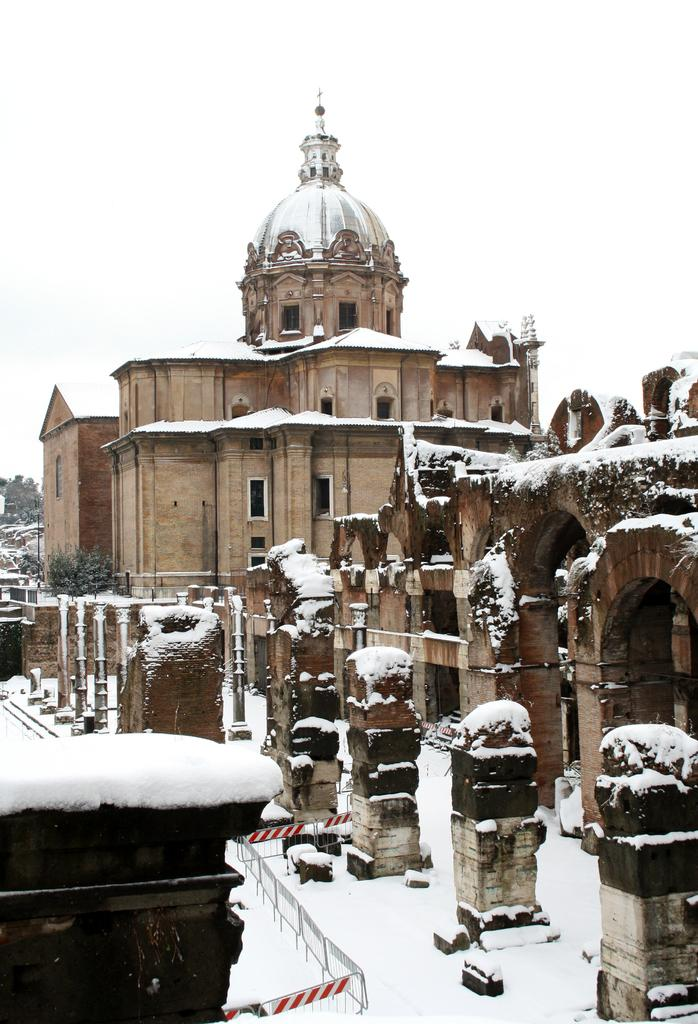What type of structure is in the image? There is a fort in the image. What type of vegetation is present in the image? There are trees in the image. What material is used for the rods visible in the image? The rods visible in the image are made of metal. What type of house is depicted in the image? There is no house depicted in the image; it features a fort. What thrilling activity is taking place in the image? There is no thrilling activity depicted in the image; it shows a fort and trees. 